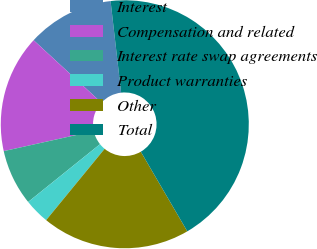<chart> <loc_0><loc_0><loc_500><loc_500><pie_chart><fcel>Interest<fcel>Compensation and related<fcel>Interest rate swap agreements<fcel>Product warranties<fcel>Other<fcel>Total<nl><fcel>11.32%<fcel>15.33%<fcel>7.3%<fcel>3.29%<fcel>19.34%<fcel>43.42%<nl></chart> 